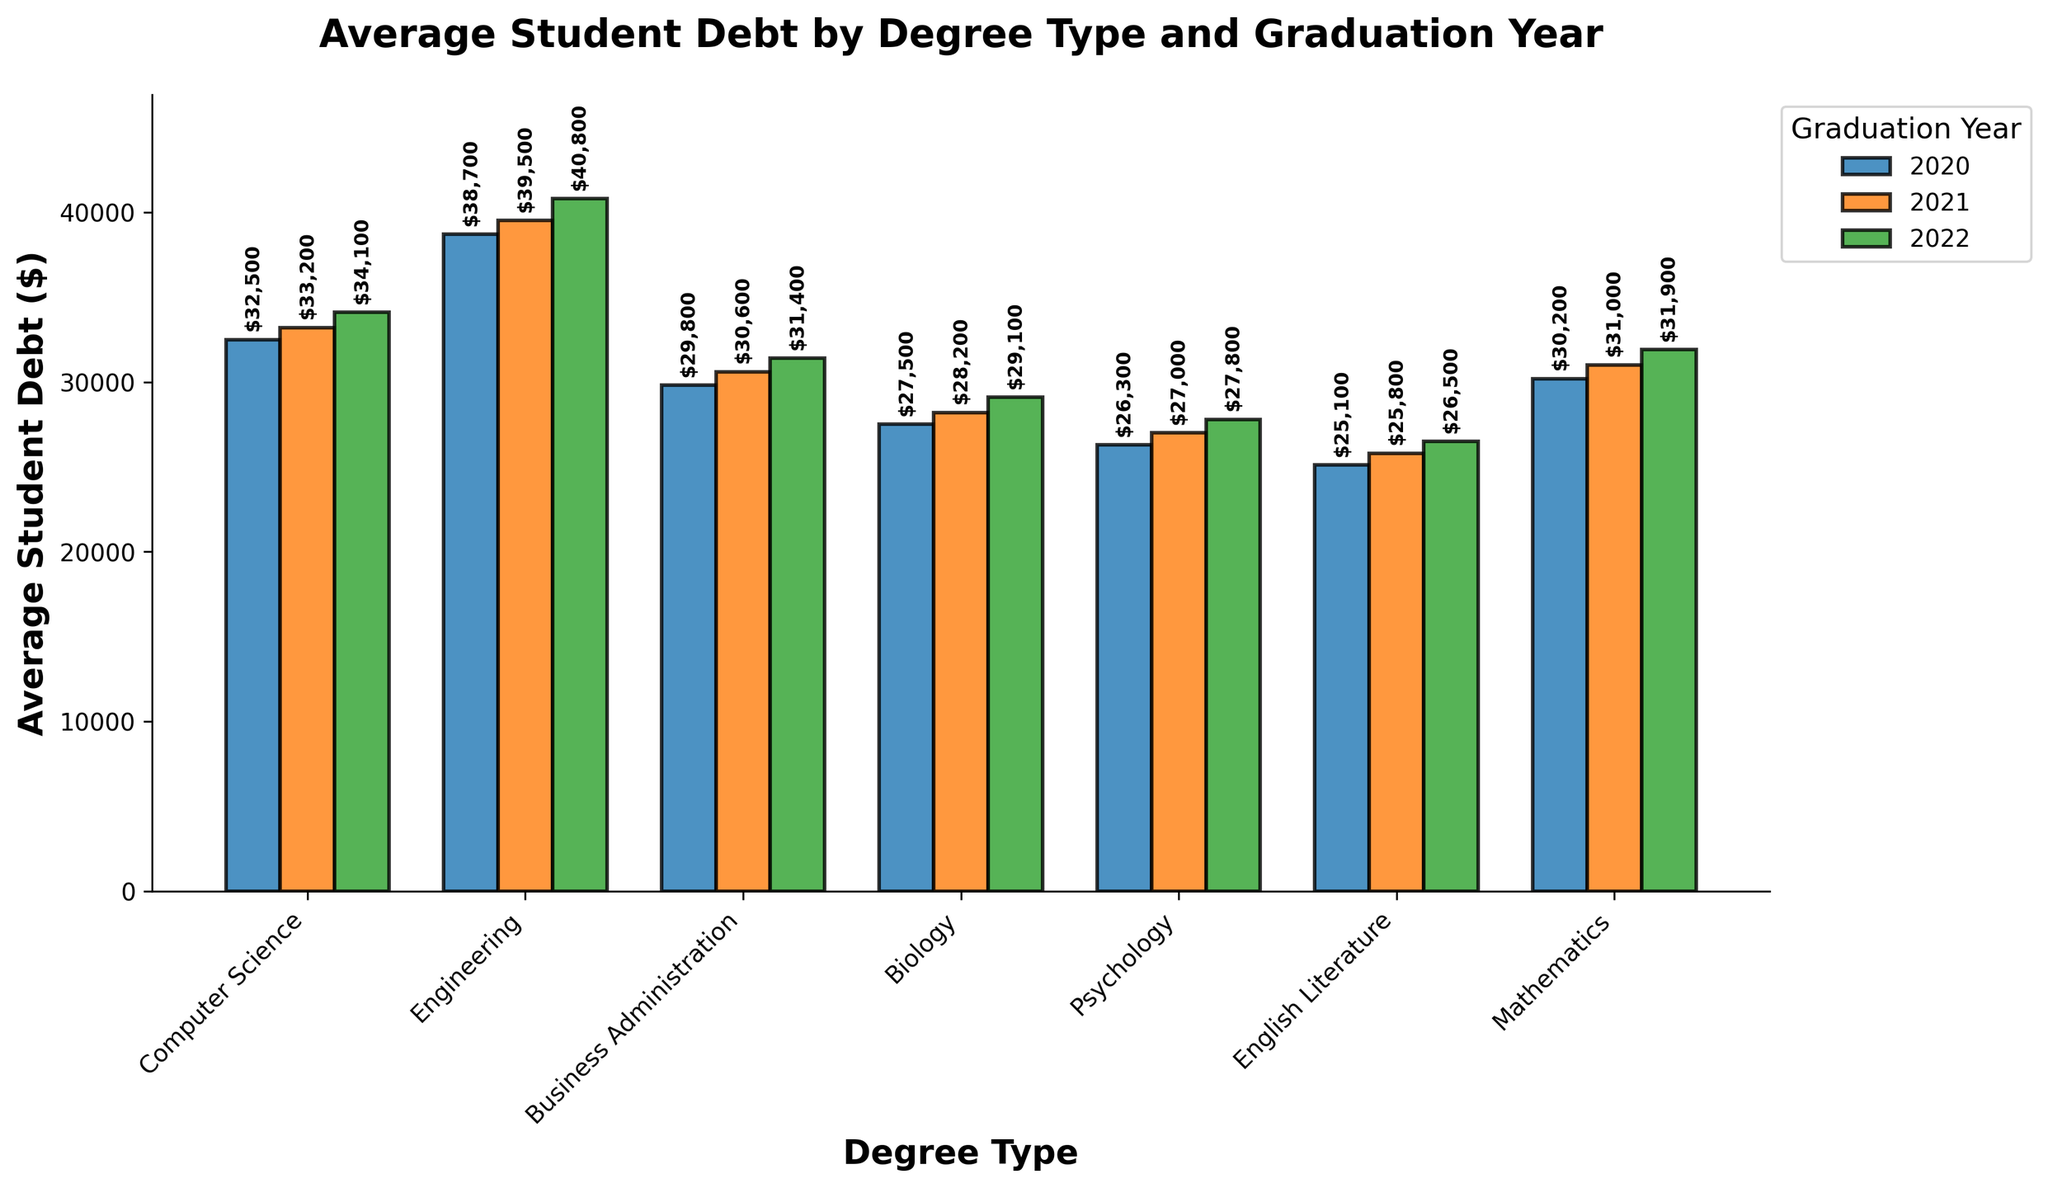What's the average student debt for Computer Science across the three years? Sum the debts for Computer Science over the three years: 32500 (2020) + 33200 (2021) + 34100 (2022) = 99800. Divide by 3: 99800/3 = 33266.67
Answer: $33,266.67 Which degree type saw the largest increase in average student debt from 2020 to 2022? Calculate the increase from 2020 to 2022 for each degree type: 
- Computer Science: 34100 - 32500 = 1600 
- Engineering: 40800 - 38700 = 2100 
- Business Administration: 31400 - 29800 = 1600 
- Biology: 29100 - 27500 = 1600 
- Psychology: 27800 - 26300 = 1500 
- English Literature: 26500 - 25100 = 1400 
- Mathematics: 31900 - 30200 = 1700. 
Engineering has the largest increase.
Answer: Engineering Which degree type has the lowest average student debt in 2022? Identify the bar with the lowest value for the year 2022: English Literature has the lowest debt at $26,500.
Answer: English Literature What is the total average student debt for Business Administration over the three years? Sum the debts for Business Administration over the three years: 29800 (2020) + 30600 (2021) + 31400 (2022) = 91800
Answer: $91,800 How does the average student debt for Mathematics in 2021 compare to Psychology in the same year? Mathematics in 2021: $31,000. Psychology in 2021: $27,000. The difference is 31000 - 27000 = 4000. Mathematics has higher debt by $4,000.
Answer: Mathematics is $4,000 higher Which degree type displayed the smallest debt increase between 2021 and 2022? Calculate the increase from 2021 to 2022 for each degree type: 
- Computer Science: 34100 - 33200 = 900 
- Engineering: 40800 - 39500 = 1300 
- Business Administration: 31400 - 30600 = 800 
- Biology: 29100 - 28200 = 900 
- Psychology: 27800 - 27000 = 800 
- English Literature: 26500 - 25800 = 700 
- Mathematics: 31900 - 31000 = 900. 
English Literature has the smallest increase.
Answer: English Literature Which year had the highest average student debt for all degrees combined? Sum the average student debts for each degree in each year and compare: 
- 2020: 32500 (CS) + 38700 (ENG) + 29800 (BA) + 27500 (BIO) + 26300 (PSY) + 25100 (EL) + 30200 (MATH) = 210100 
- 2021: 33200 (CS) + 39500 (ENG) + 30600 (BA) + 28200 (BIO) + 27000 (PSY) + 25800 (EL) + 31000 (MATH) = 215300 
- 2022: 34100 (CS) + 40800 (ENG) + 31400 (BA) + 29100 (BIO) + 27800 (PSY) + 26500 (EL) + 31900 (MATH) = 221600. 
Year 2022 had the highest total debt.
Answer: 2022 What's the average student debt for all degrees in 2022? Sum the 2022 debts for all degrees: 34100 (CS) + 40800 (ENG) + 31400 (BA) + 29100 (BIO) + 27800 (PSY) + 26500 (EL) + 31900 (MATH) = 221600. Divide by 7 (number of degree types): 221600/7 = 31657.14
Answer: $31,657.14 